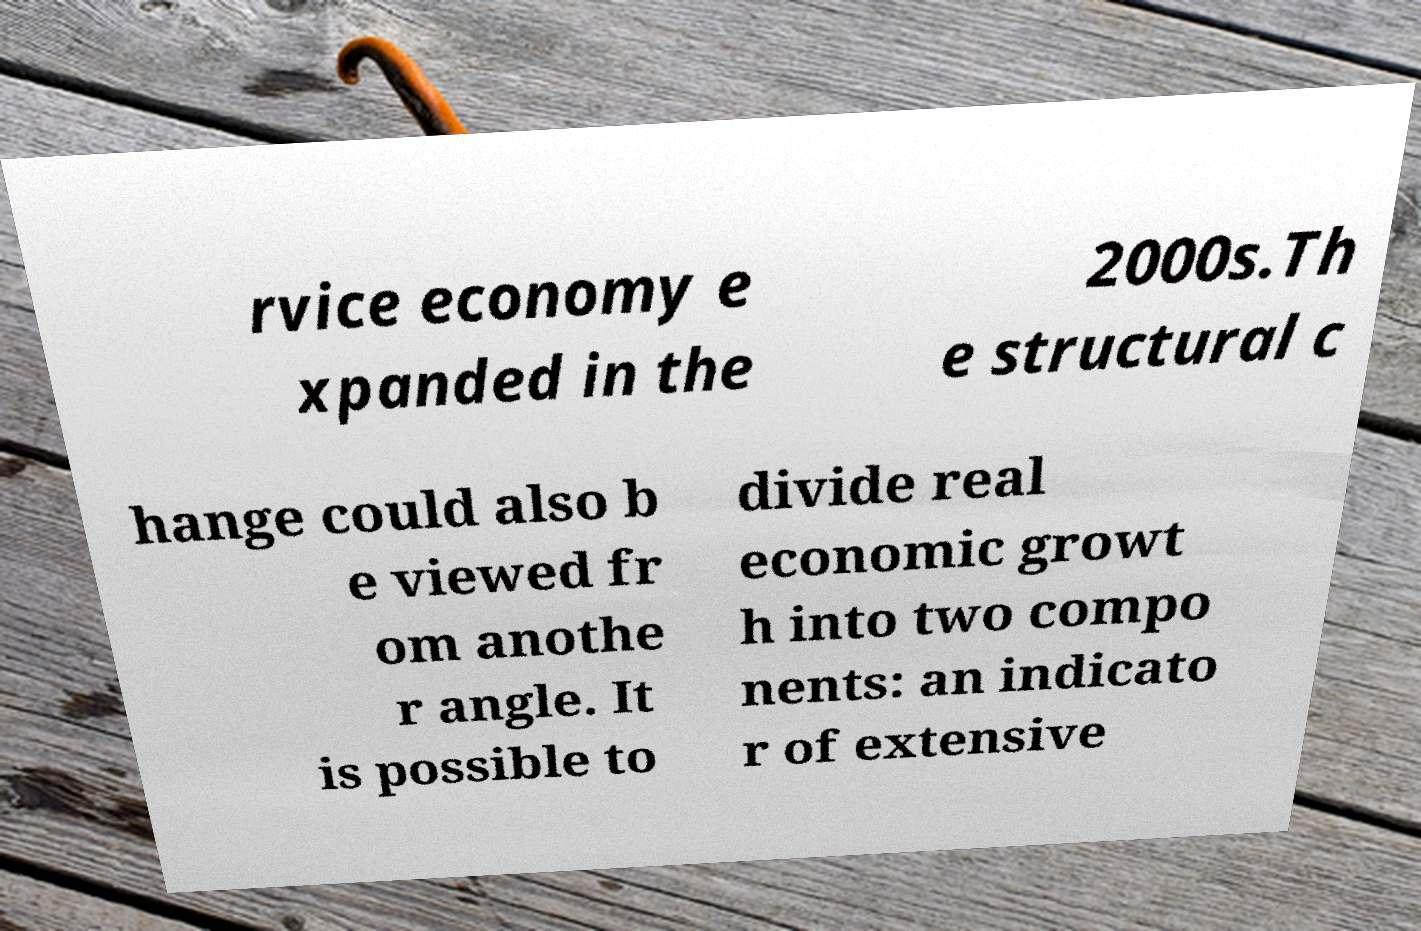Can you accurately transcribe the text from the provided image for me? rvice economy e xpanded in the 2000s.Th e structural c hange could also b e viewed fr om anothe r angle. It is possible to divide real economic growt h into two compo nents: an indicato r of extensive 